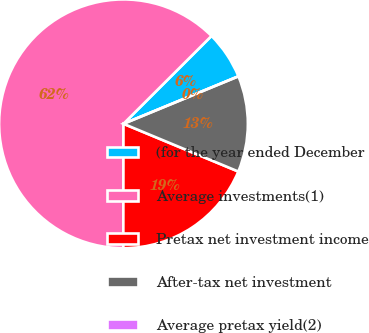Convert chart to OTSL. <chart><loc_0><loc_0><loc_500><loc_500><pie_chart><fcel>(for the year ended December<fcel>Average investments(1)<fcel>Pretax net investment income<fcel>After-tax net investment<fcel>Average pretax yield(2)<nl><fcel>6.25%<fcel>62.49%<fcel>18.75%<fcel>12.5%<fcel>0.0%<nl></chart> 